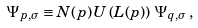<formula> <loc_0><loc_0><loc_500><loc_500>\Psi _ { p , \sigma } \equiv N ( p ) \, U \left ( L ( p ) \right ) \, \Psi _ { q , \sigma } \, ,</formula> 